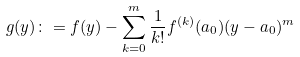Convert formula to latex. <formula><loc_0><loc_0><loc_500><loc_500>g ( y ) \colon = f ( y ) - \sum _ { k = 0 } ^ { m } \frac { 1 } { k ! } f ^ { ( k ) } ( a _ { 0 } ) ( y - a _ { 0 } ) ^ { m }</formula> 